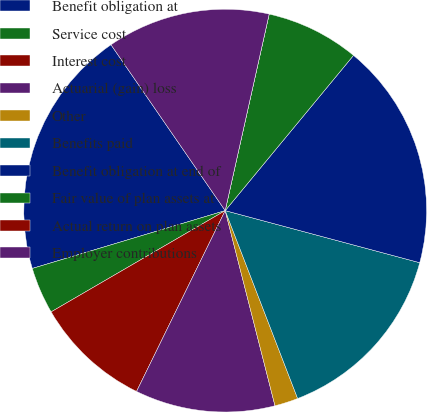Convert chart. <chart><loc_0><loc_0><loc_500><loc_500><pie_chart><fcel>Benefit obligation at<fcel>Service cost<fcel>Interest cost<fcel>Actuarial (gain) loss<fcel>Other<fcel>Benefits paid<fcel>Benefit obligation at end of<fcel>Fair value of plan assets at<fcel>Actual return on plan assets<fcel>Employer contributions<nl><fcel>20.04%<fcel>3.75%<fcel>9.36%<fcel>11.23%<fcel>1.88%<fcel>14.98%<fcel>18.17%<fcel>7.49%<fcel>0.0%<fcel>13.1%<nl></chart> 